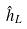<formula> <loc_0><loc_0><loc_500><loc_500>\hat { h } _ { L }</formula> 